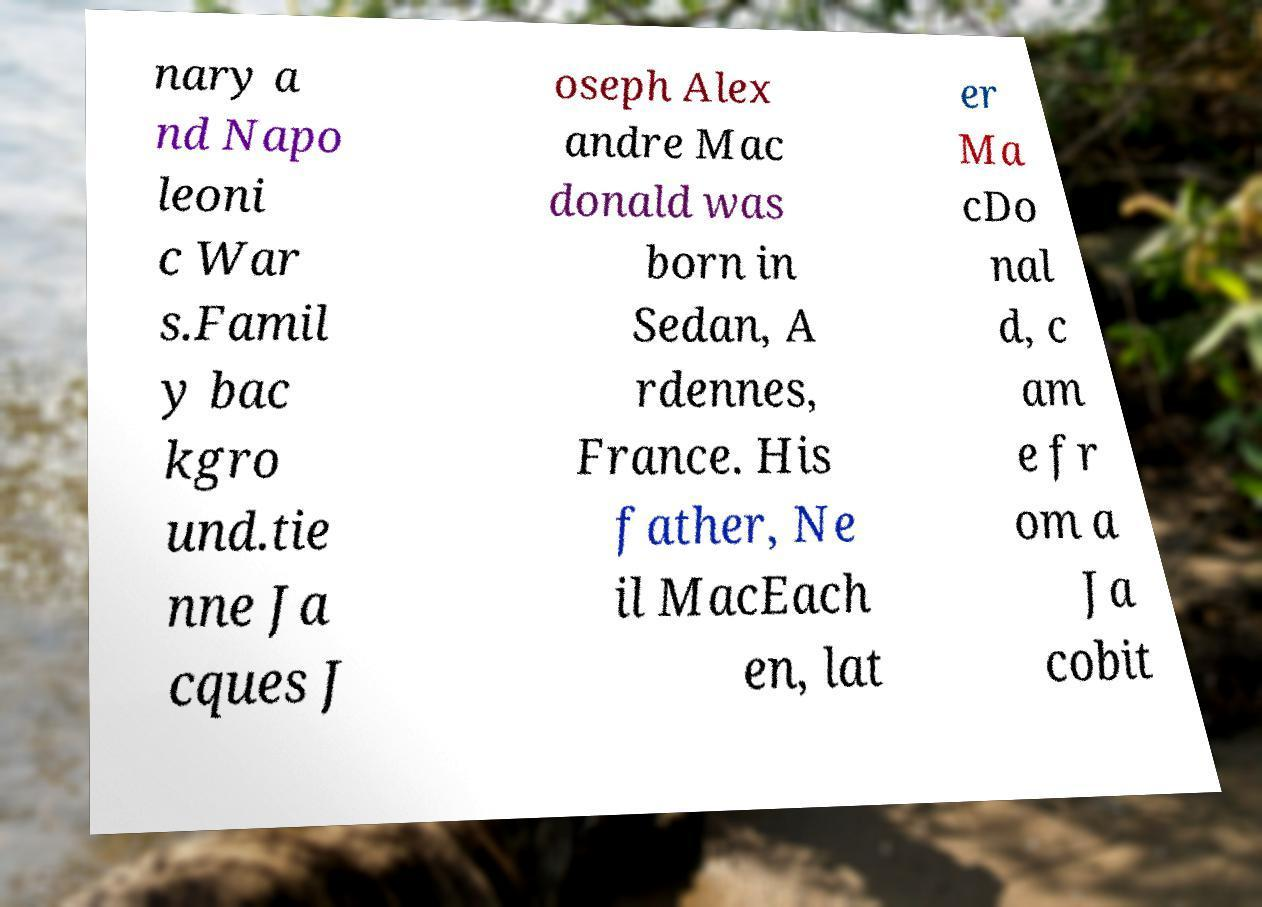For documentation purposes, I need the text within this image transcribed. Could you provide that? nary a nd Napo leoni c War s.Famil y bac kgro und.tie nne Ja cques J oseph Alex andre Mac donald was born in Sedan, A rdennes, France. His father, Ne il MacEach en, lat er Ma cDo nal d, c am e fr om a Ja cobit 